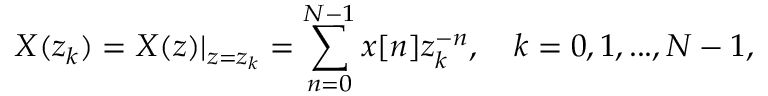<formula> <loc_0><loc_0><loc_500><loc_500>X ( z _ { k } ) = X ( z ) | _ { z = z _ { k } } = \sum _ { n = 0 } ^ { N - 1 } x [ n ] z _ { k } ^ { - n } , \quad k = 0 , 1 , \dots , N - 1 ,</formula> 